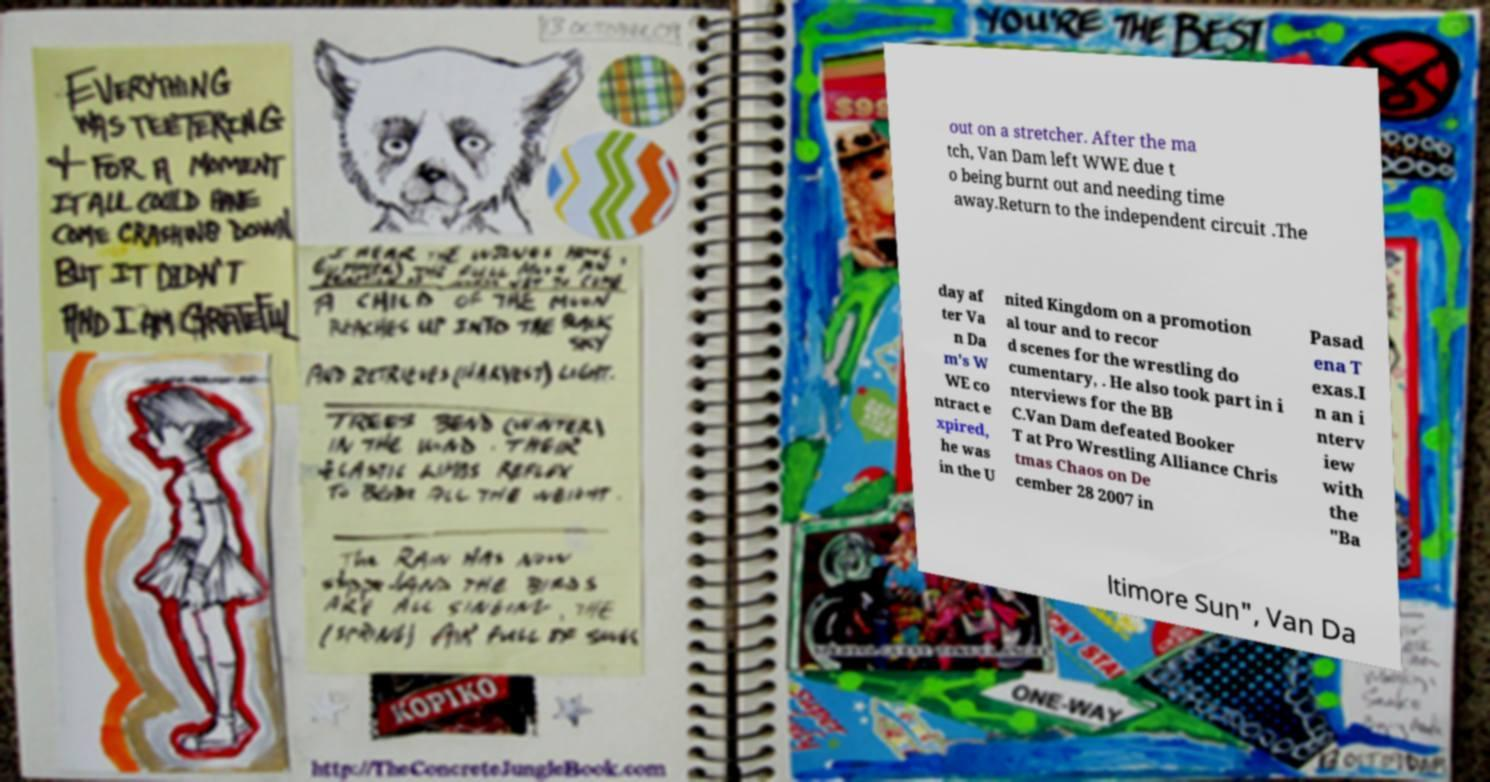Please identify and transcribe the text found in this image. out on a stretcher. After the ma tch, Van Dam left WWE due t o being burnt out and needing time away.Return to the independent circuit .The day af ter Va n Da m's W WE co ntract e xpired, he was in the U nited Kingdom on a promotion al tour and to recor d scenes for the wrestling do cumentary, . He also took part in i nterviews for the BB C.Van Dam defeated Booker T at Pro Wrestling Alliance Chris tmas Chaos on De cember 28 2007 in Pasad ena T exas.I n an i nterv iew with the "Ba ltimore Sun", Van Da 